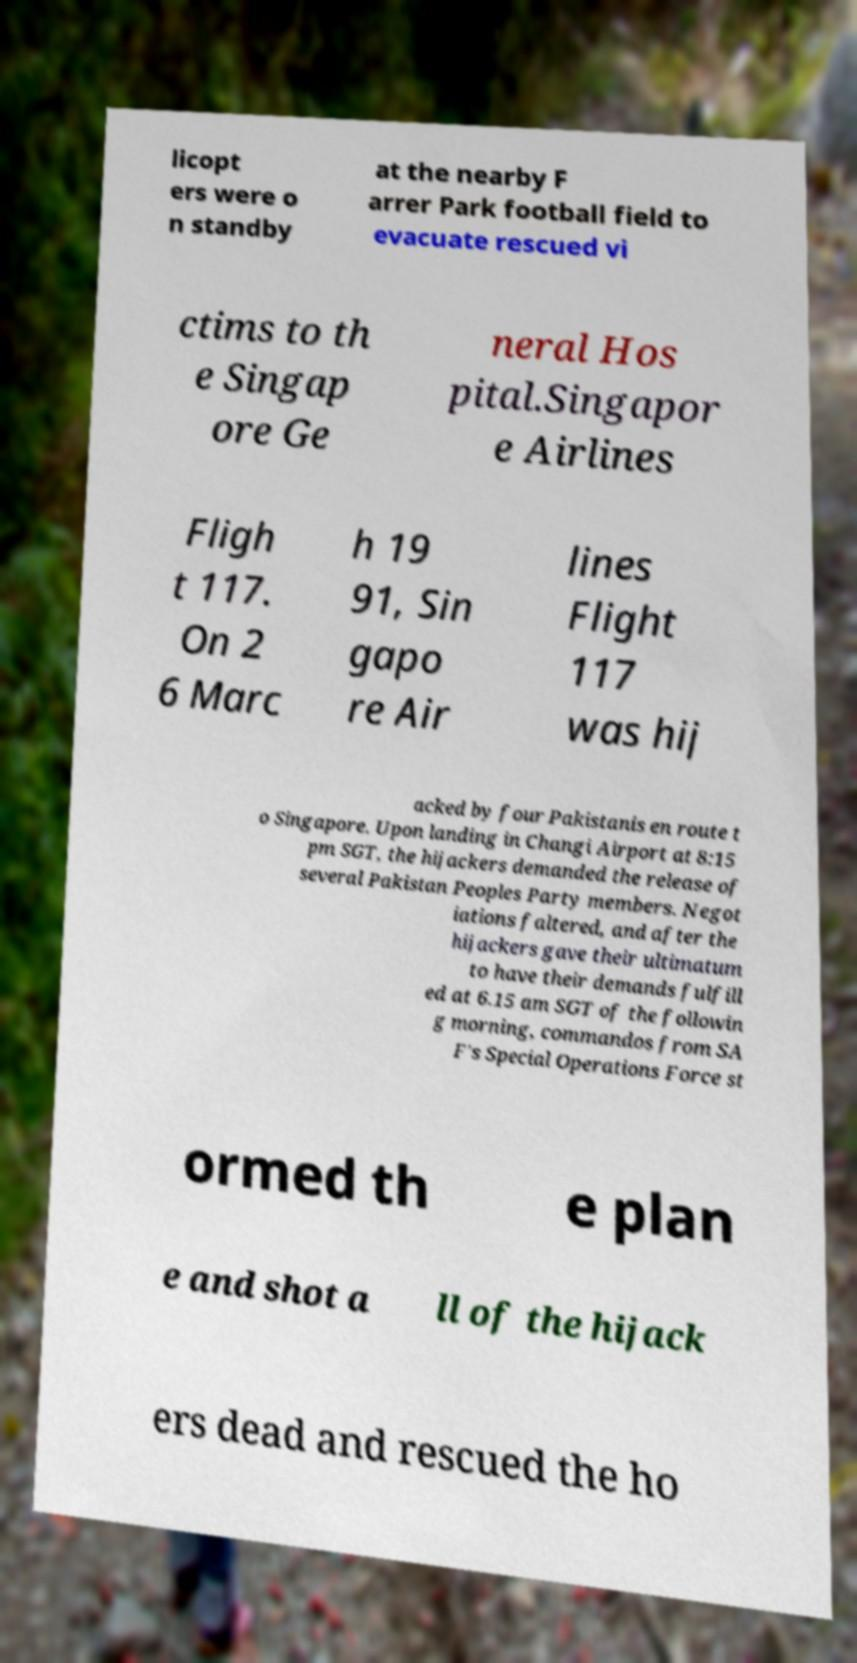For documentation purposes, I need the text within this image transcribed. Could you provide that? licopt ers were o n standby at the nearby F arrer Park football field to evacuate rescued vi ctims to th e Singap ore Ge neral Hos pital.Singapor e Airlines Fligh t 117. On 2 6 Marc h 19 91, Sin gapo re Air lines Flight 117 was hij acked by four Pakistanis en route t o Singapore. Upon landing in Changi Airport at 8:15 pm SGT, the hijackers demanded the release of several Pakistan Peoples Party members. Negot iations faltered, and after the hijackers gave their ultimatum to have their demands fulfill ed at 6.15 am SGT of the followin g morning, commandos from SA F's Special Operations Force st ormed th e plan e and shot a ll of the hijack ers dead and rescued the ho 